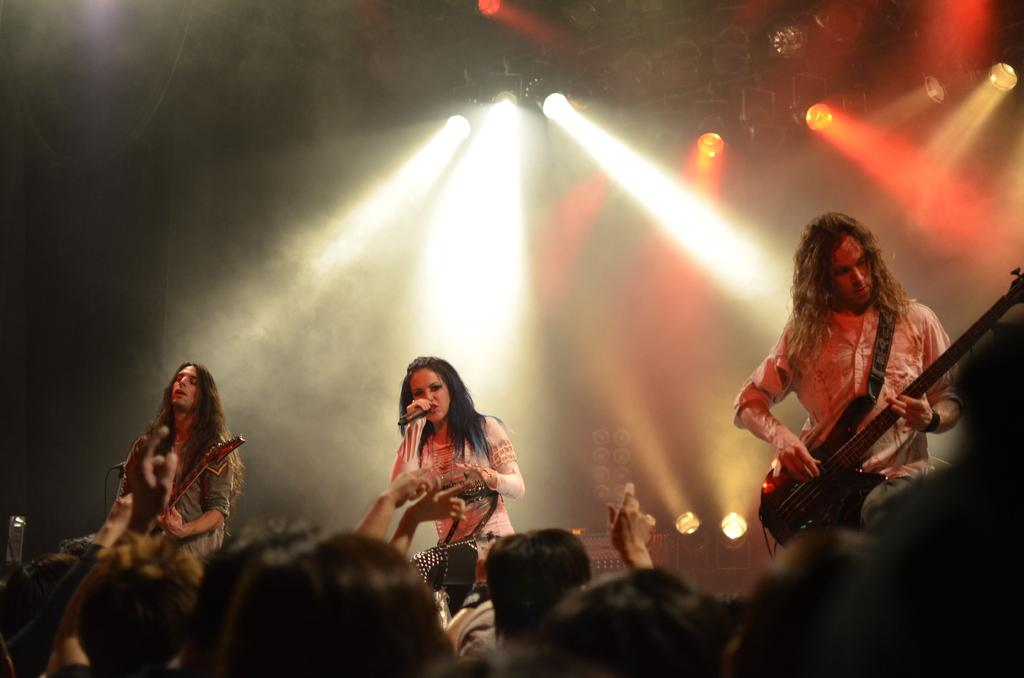What is happening on the stage in the image? There are people on a stage, and at least one person is playing a guitar. Can you describe the woman on the stage? The woman on the stage is singing into a microphone. What instrument is being played by one of the people on the stage? At least one person is playing a guitar. What type of notebook is the woman using to write her lyrics on the stage? There is no notebook present in the image, and the woman is not shown writing lyrics. 